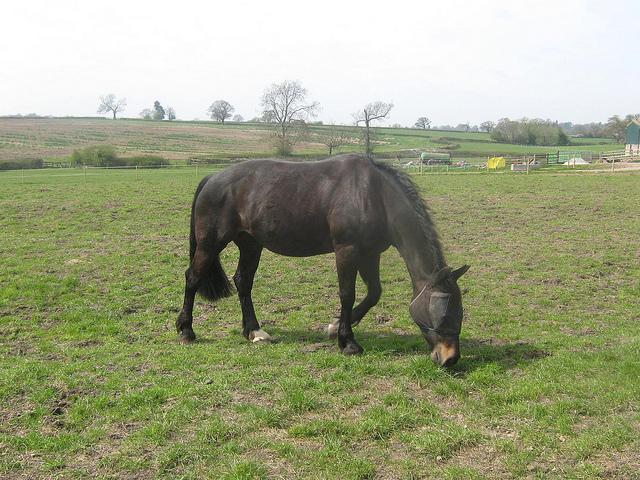How many people in the image are sitting?
Give a very brief answer. 0. 